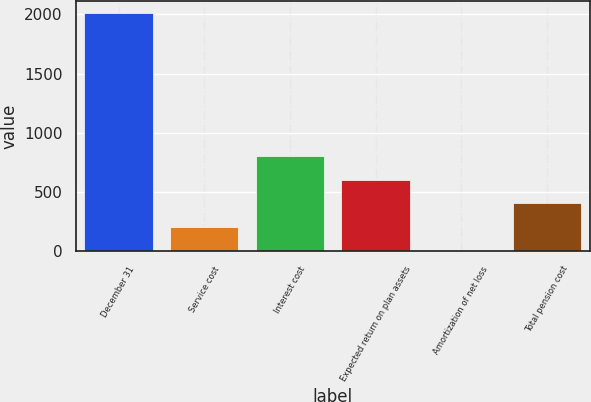Convert chart. <chart><loc_0><loc_0><loc_500><loc_500><bar_chart><fcel>December 31<fcel>Service cost<fcel>Interest cost<fcel>Expected return on plan assets<fcel>Amortization of net loss<fcel>Total pension cost<nl><fcel>2016<fcel>203.4<fcel>807.6<fcel>606.2<fcel>2<fcel>404.8<nl></chart> 